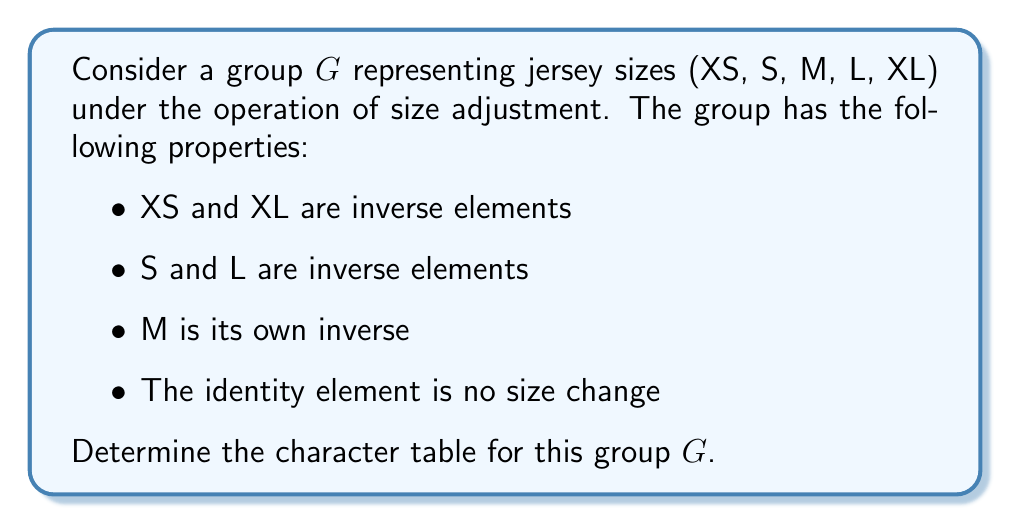Provide a solution to this math problem. To determine the character table for group $G$, we'll follow these steps:

1) First, identify the order of the group and its conjugacy classes:
   The group has 5 elements: {e, XS, S, M, L, XL}
   Order of G: $|G| = 5$

   Conjugacy classes:
   $\{e\}$, $\{XS, XL\}$, $\{S, L\}$, $\{M\}$

2) The number of irreducible representations is equal to the number of conjugacy classes, which is 4.

3) The dimensions of the irreducible representations must satisfy:
   $1^2 + 1^2 + 1^2 + 1^2 = 5$
   So, all irreducible representations are 1-dimensional.

4) For a group of order 5, we know it's abelian (since all groups of prime order are cyclic and thus abelian). For abelian groups, all irreducible representations are 1-dimensional.

5) The character table will have 4 rows (one for each irreducible representation) and 4 columns (one for each conjugacy class).

6) The first row of the character table always corresponds to the trivial representation, which assigns 1 to all elements.

7) For the remaining rows, we can use the properties of characters for abelian groups:
   - Characters are homomorphisms from G to C*
   - The values must be 5th roots of unity (since |G| = 5)
   - The 5th roots of unity are $1, e^{2\pi i/5}, e^{4\pi i/5}, e^{6\pi i/5}, e^{8\pi i/5}$

8) Construct the character table:

   $$\begin{array}{c|cccc}
      & \{e\} & \{XS,XL\} & \{S,L\} & \{M\} \\
   \hline
   \chi_1 & 1 & 1 & 1 & 1 \\
   \chi_2 & 1 & e^{2\pi i/5} & e^{4\pi i/5} & e^{6\pi i/5} \\
   \chi_3 & 1 & e^{4\pi i/5} & e^{8\pi i/5} & e^{2\pi i/5} \\
   \chi_4 & 1 & e^{6\pi i/5} & e^{2\pi i/5} & e^{8\pi i/5}
   \end{array}$$

This completes the character table for the group $G$.
Answer: $$\begin{array}{c|cccc}
   & \{e\} & \{XS,XL\} & \{S,L\} & \{M\} \\
\hline
\chi_1 & 1 & 1 & 1 & 1 \\
\chi_2 & 1 & e^{2\pi i/5} & e^{4\pi i/5} & e^{6\pi i/5} \\
\chi_3 & 1 & e^{4\pi i/5} & e^{8\pi i/5} & e^{2\pi i/5} \\
\chi_4 & 1 & e^{6\pi i/5} & e^{2\pi i/5} & e^{8\pi i/5}
\end{array}$$ 